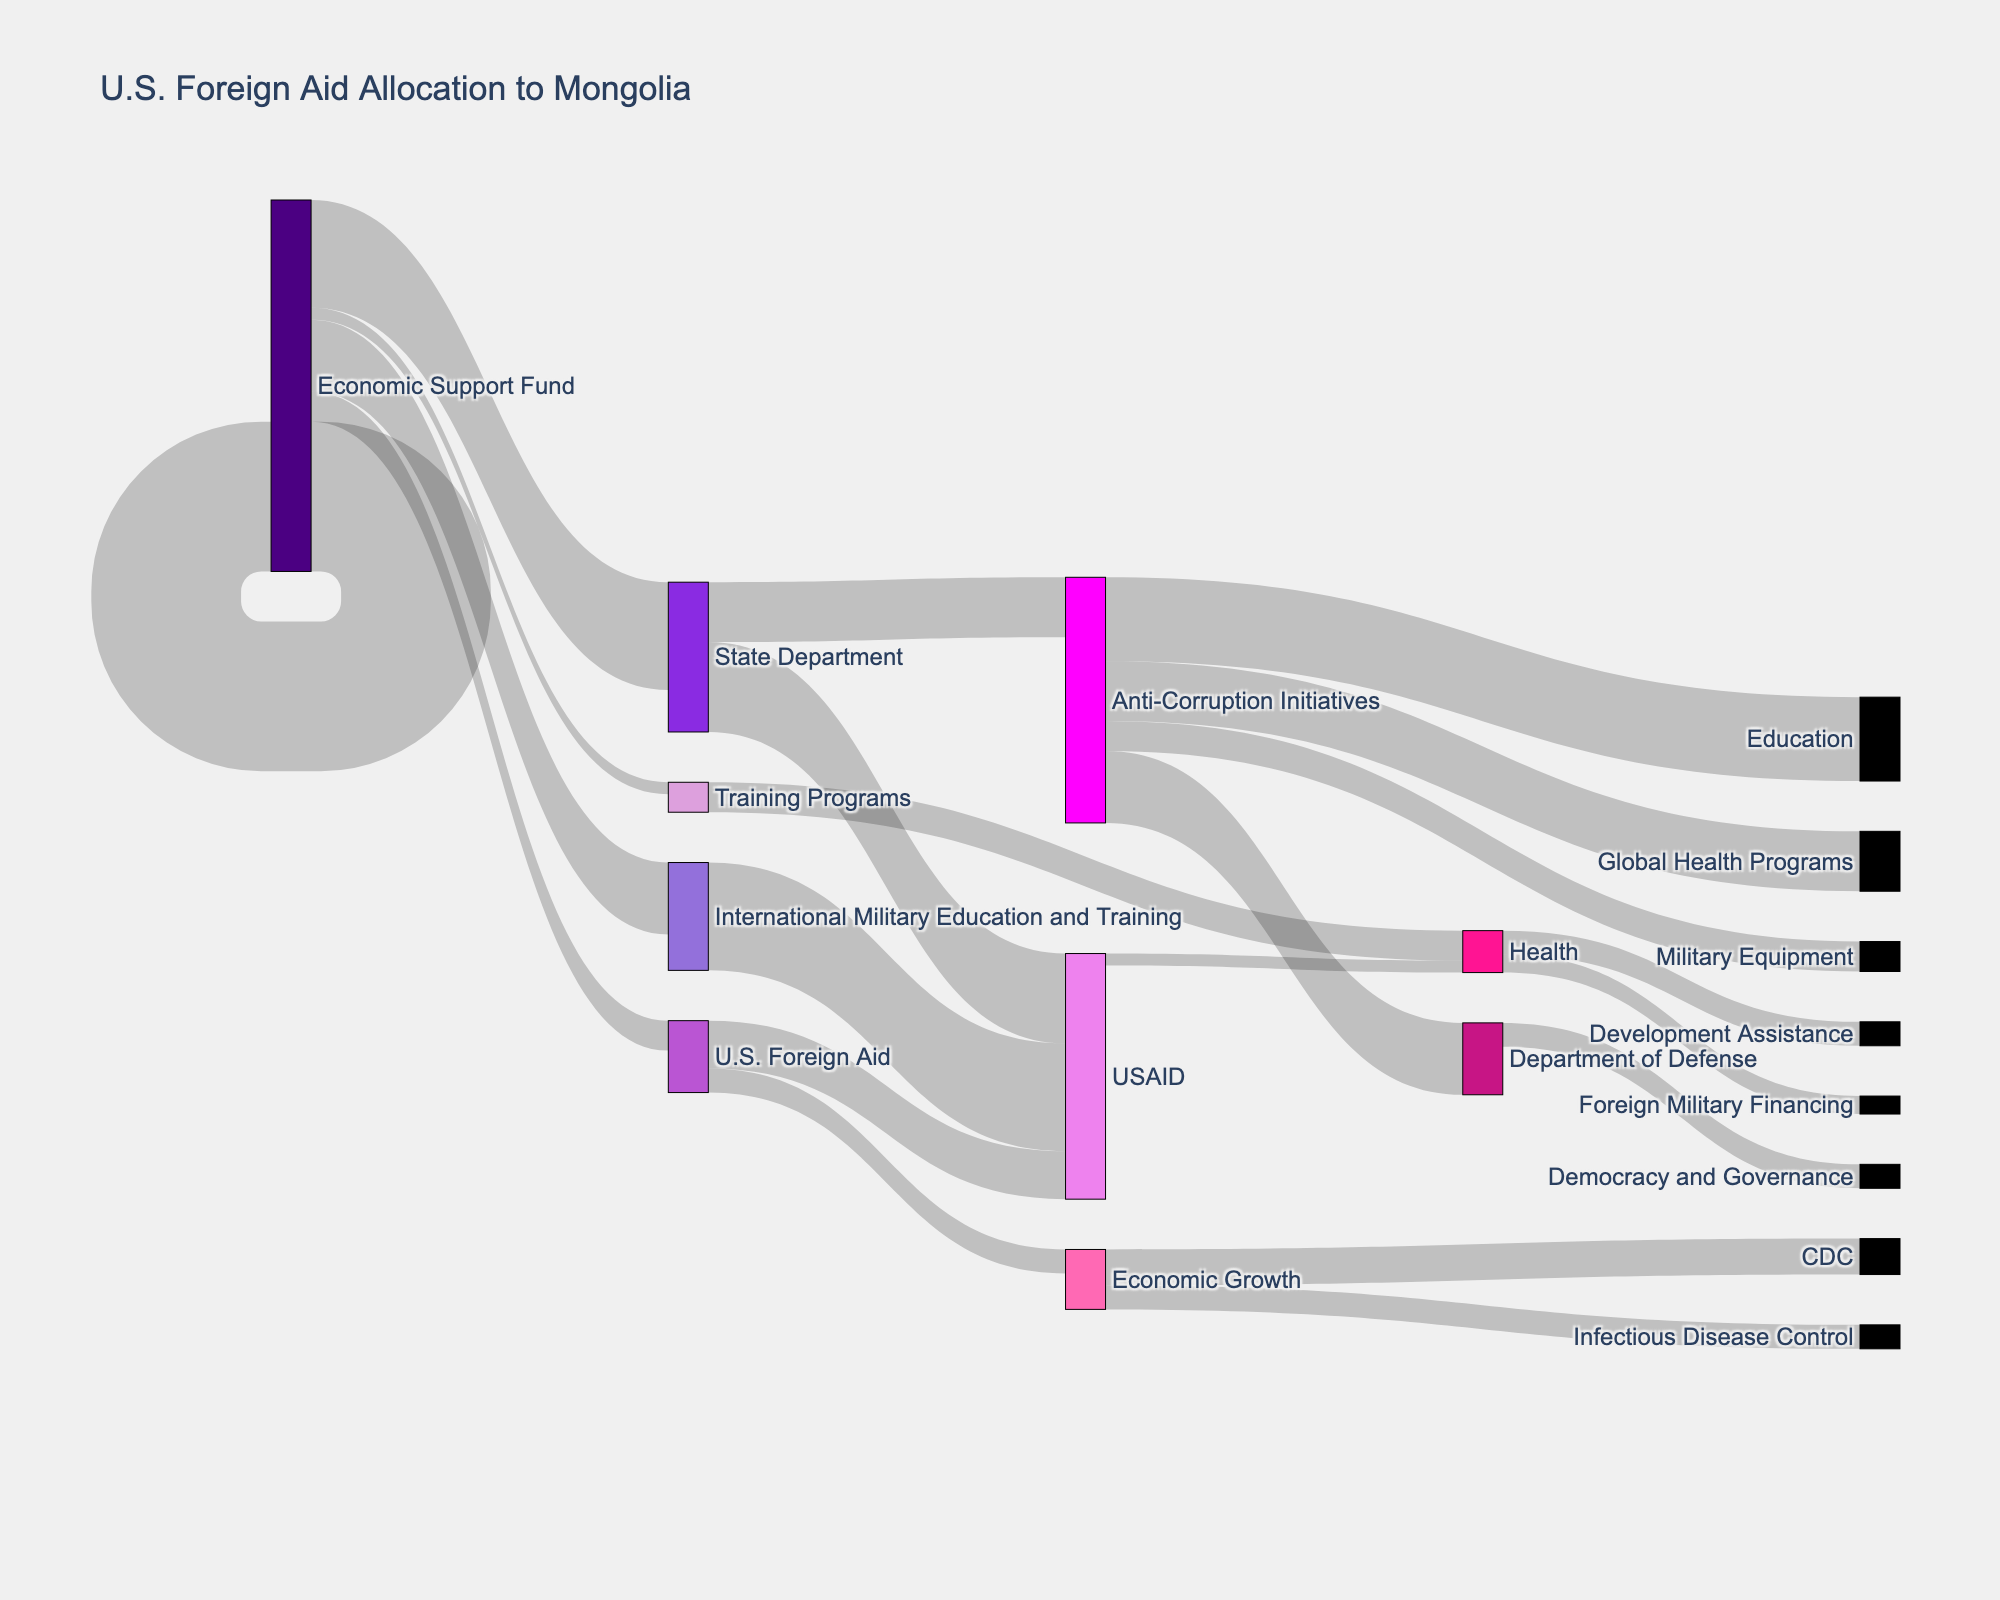what is the title of the figure? The title of the figure is usually displayed at the top. For this Sankey diagram, the title is "U.S. Foreign Aid Allocation to Mongolia" as indicated in the layout settings.
Answer: U.S. Foreign Aid Allocation to Mongolia Which program category receives the highest allocation of U.S. foreign aid? To find this, look for the largest value associated with a direct link from "U.S. Foreign Aid". The "Economic Support Fund" receives 25 units, which is the highest.
Answer: Economic Support Fund How much total aid is directed towards health programs through different agencies? Identify the aid directed to health programs by summing the values linked to "Global Health Programs" (12 units total) and the value linked to "Health" under USAID (10 units). Therefore, the total is 12 + 10.
Answer: 22 Which implementing agency handles the most diverse range of program categories? Look at the number of unique program categories linked to each agency. USAID handles 4 categories (Democracy and Governance, Economic Growth, Health, Education), which is the most diverse.
Answer: USAID Which agency handles 'Anti-Corruption Initiatives' and what is the amount allocated? Find the link that mentions 'Anti-Corruption Initiatives' and follow it back to its source. The State Department handles this, with an amount of 4 units.
Answer: State Department, 4 units Compare the funding for 'Training Programs' and 'Military Equipment'. Which one receives more and by how much? Find the links for 'Training Programs' and 'Military Equipment' under the Department of Defense. 'Training Programs' gets 4 units, 'Military Equipment' gets 3 units. The difference is 1 unit more for 'Training Programs'.
Answer: Training Programs by 1 unit What percentage of Development Assistance is managed by USAID? "Development Assistance" is entirely managed by USAID, as shown by a single link with 18 units. Since there's only one link, it is 100%.
Answer: 100% How is the aid within the 'Economic Support Fund' category distributed among different agencies? Look at the links from 'Economic Support Fund'. USAID gets 15 units and the State Department gets 10 units.
Answer: USAID: 15 units, State Department: 10 units What is the total amount of U.S. Foreign Aid allocated to military-related programs? Sum the values linked to "Foreign Military Financing" (5 units) and "International Military Education and Training" (2 units). Total is 5 + 2.
Answer: 7 